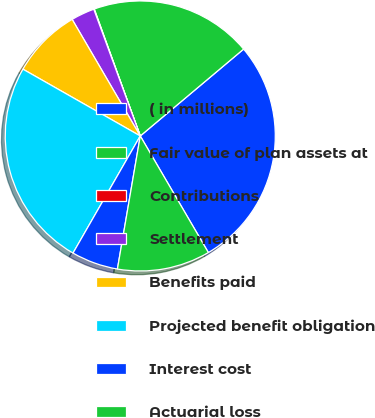<chart> <loc_0><loc_0><loc_500><loc_500><pie_chart><fcel>( in millions)<fcel>Fair value of plan assets at<fcel>Contributions<fcel>Settlement<fcel>Benefits paid<fcel>Projected benefit obligation<fcel>Interest cost<fcel>Actuarial loss<nl><fcel>27.71%<fcel>19.41%<fcel>0.06%<fcel>2.82%<fcel>8.35%<fcel>24.94%<fcel>5.59%<fcel>11.12%<nl></chart> 